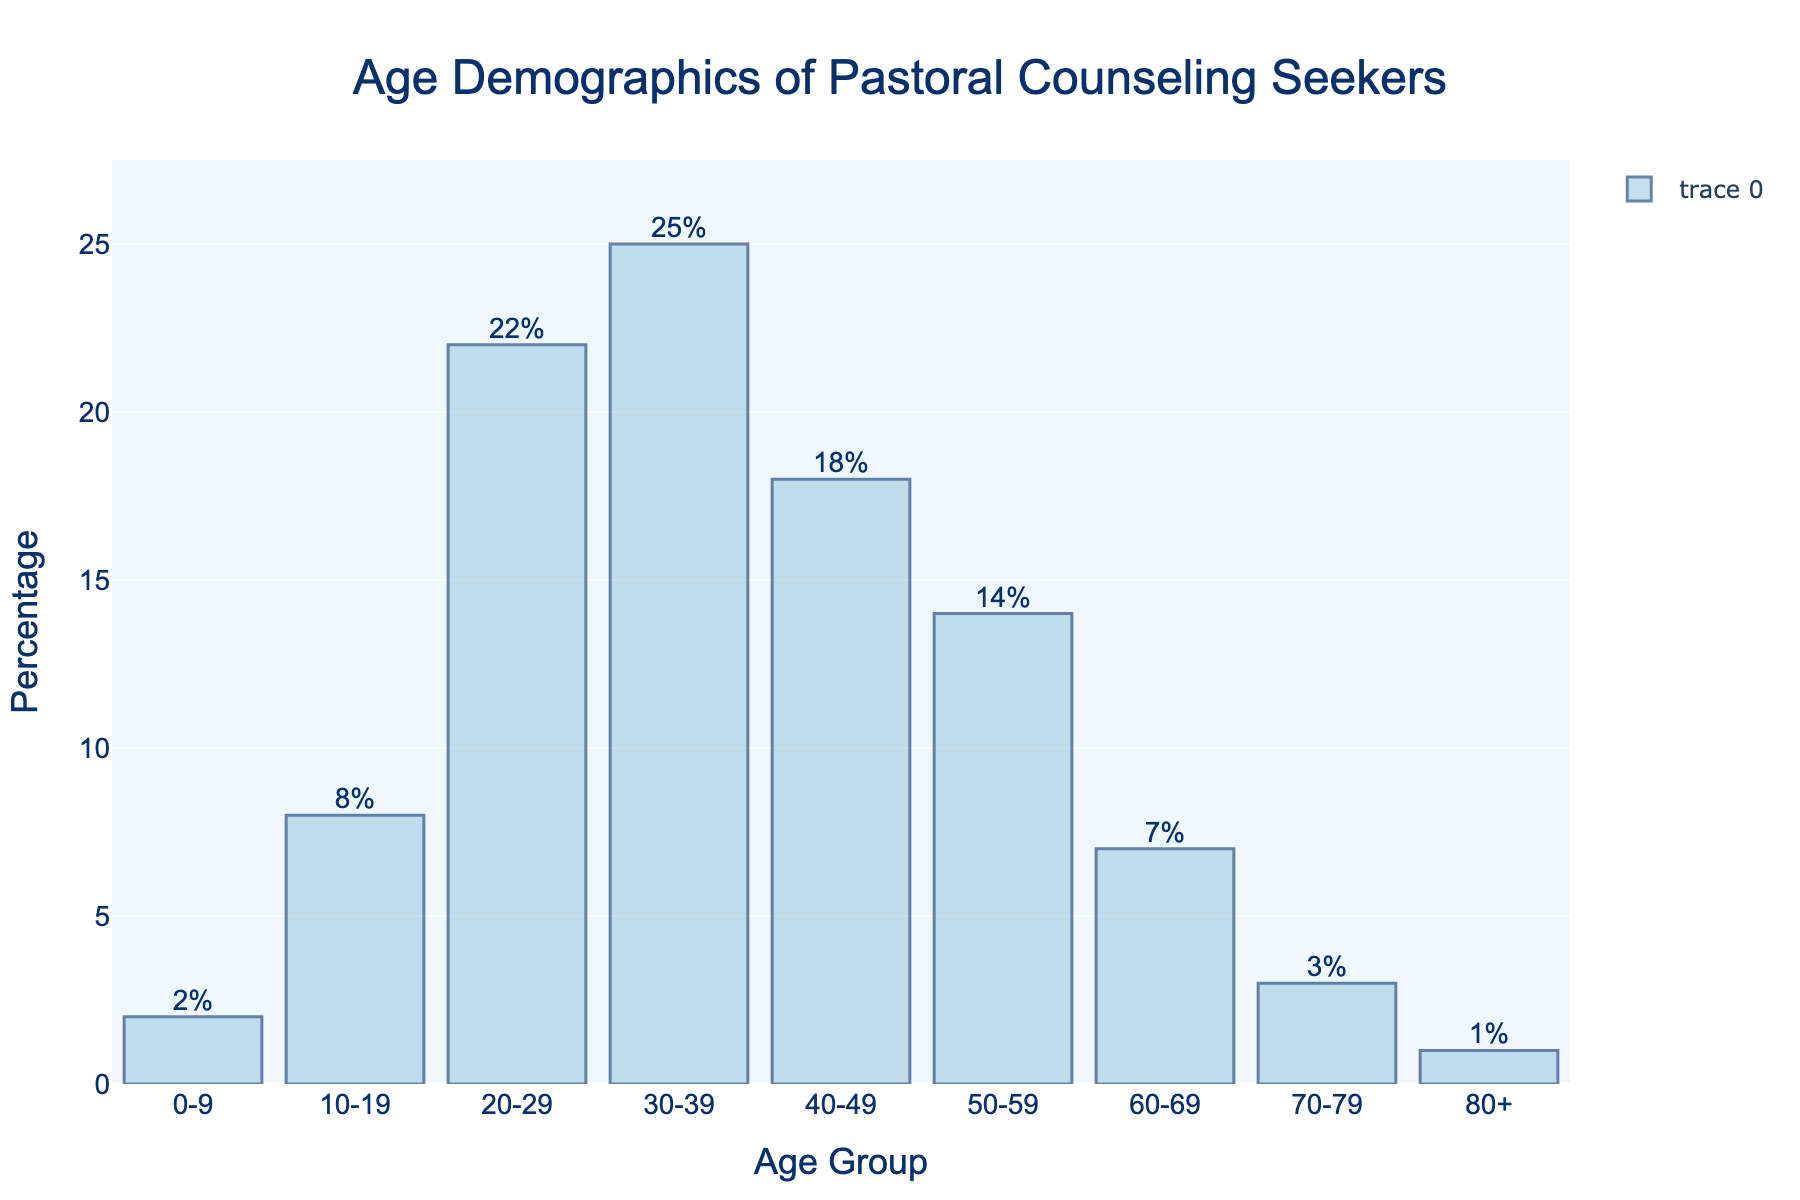What age group has the highest percentage of individuals seeking pastoral counseling? The age group with the highest bar in the chart represents the highest percentage. The 30-39 age group has the tallest bar.
Answer: 30-39 Which two age groups have the combined lowest percentage of individuals seeking pastoral counseling? The 0-9 and 80+ age groups have the lowest bars in the chart. Adding their percentages: 2% + 1% = 3%.
Answer: 0-9 and 80+ What is the difference in percentage between individuals seeking pastoral counseling in the 20-29 and 30-39 age groups? The percentage for the 30-39 age group is 25%, and for the 20-29 age group, it is 22%. The difference is 25% - 22% = 3%.
Answer: 3% How does the percentage of individuals in the 40-49 age group compare with those in the 50-59 age group? The chart shows that the 40-49 age group has 18%, and the 50-59 age group has 14%. The 40-49 age group has a higher percentage.
Answer: 40-49 > 50-59 What percentage of individuals seeking counseling are in the 10-19 age group? The figure shows the percentage value directly above the bar for the 10-19 age group, which is 8%.
Answer: 8% What is the average percentage of individuals seeking pastoral counseling across all age groups? Summing up all percentages: 2% + 8% + 22% + 25% + 18% + 14% + 7% + 3% + 1% = 100%. Dividing this by the number of age groups (9) gives the average: 100% / 9 ≈ 11.11%.
Answer: ≈ 11.11% Which age group has the lowest percentage of individuals seeking pastoral counseling? The shortest bar in the chart represents the age group with the lowest percentage, which is the 80+ age group at 1%.
Answer: 80+ Are there more individuals seeking counseling in the 60-69 or 70-79 age groups? The chart shows that the 60-69 age group has 7%, while the 70-79 age group has 3%. The 60-69 age group has a higher percentage.
Answer: 60-69 What is the combined percentage of individuals seeking pastoral counseling in age groups under 20 years old? The percentages for the 0-9 age group (2%) and 10-19 age group (8%) sum up to 2% + 8% = 10%.
Answer: 10% How much percent higher is the 30-39 age group's counseling percentage compared to the 60-69 age group? The percentage for the 30-39 age group is 25%, and for the 60-69 age group, it is 7%. The difference is 25% - 7% = 18%.
Answer: 18% 